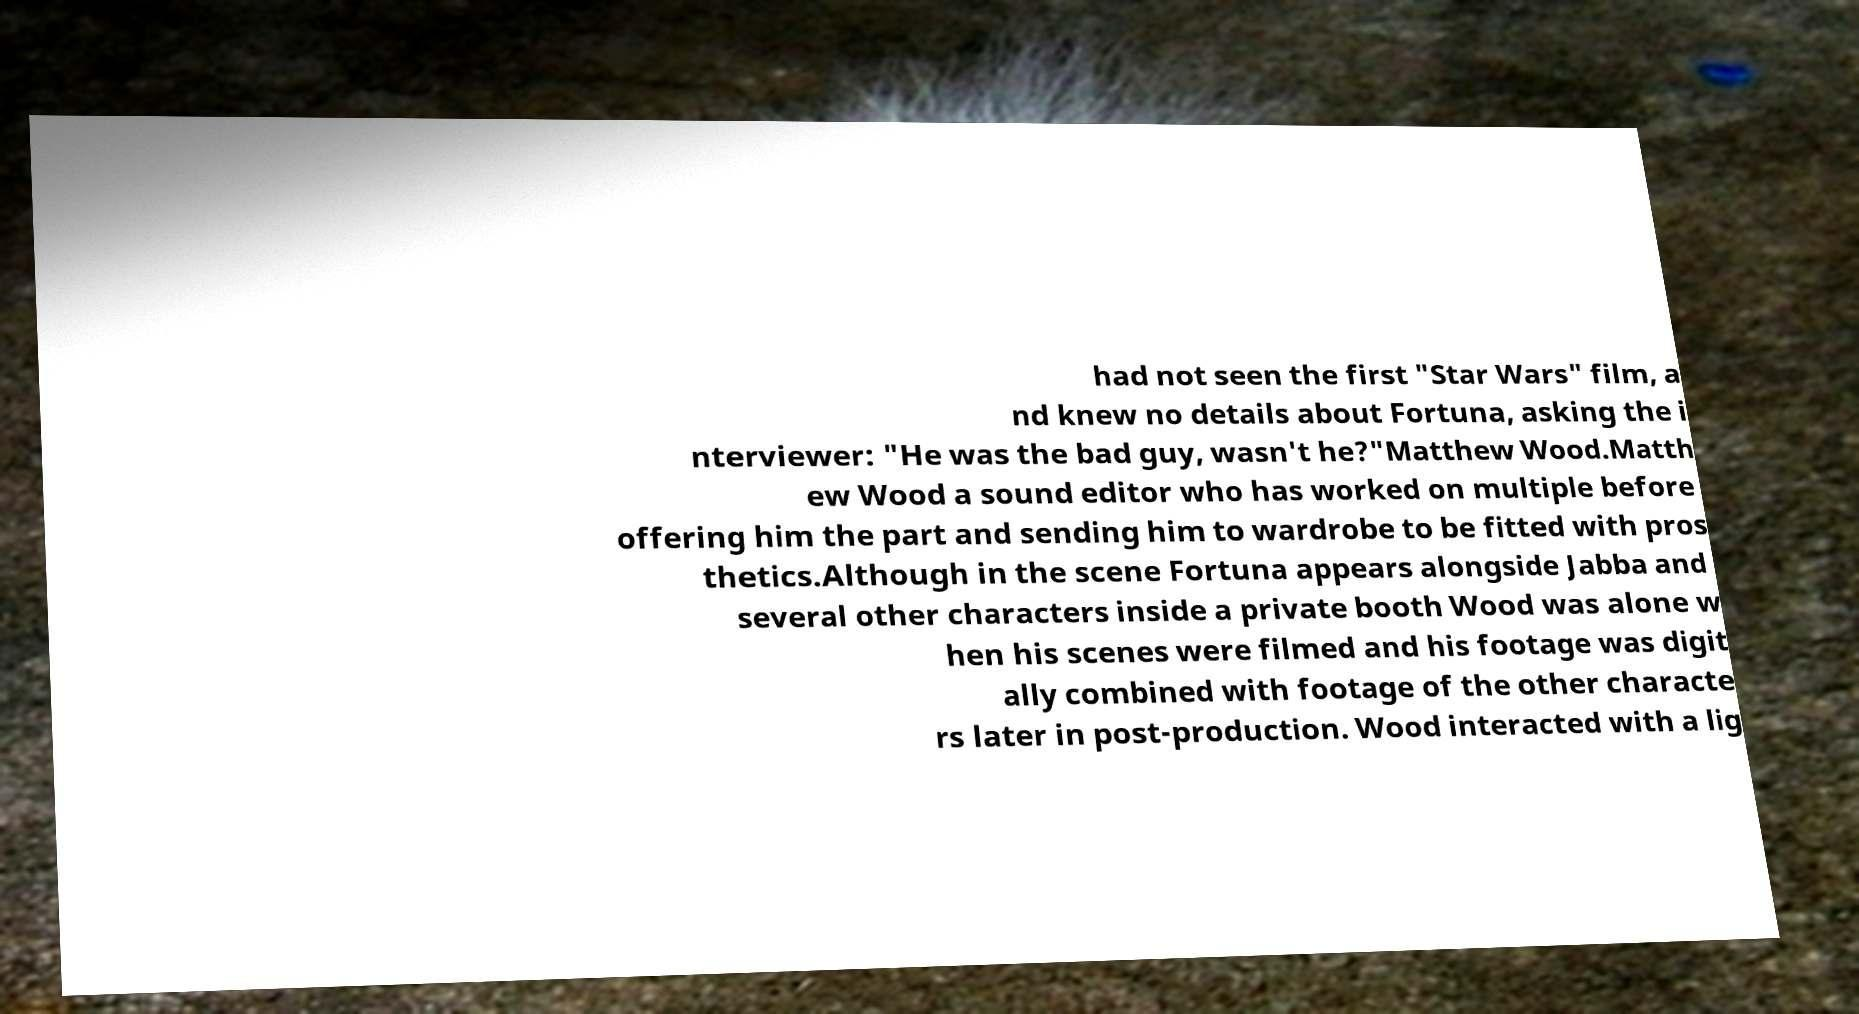Could you extract and type out the text from this image? had not seen the first "Star Wars" film, a nd knew no details about Fortuna, asking the i nterviewer: "He was the bad guy, wasn't he?"Matthew Wood.Matth ew Wood a sound editor who has worked on multiple before offering him the part and sending him to wardrobe to be fitted with pros thetics.Although in the scene Fortuna appears alongside Jabba and several other characters inside a private booth Wood was alone w hen his scenes were filmed and his footage was digit ally combined with footage of the other characte rs later in post-production. Wood interacted with a lig 